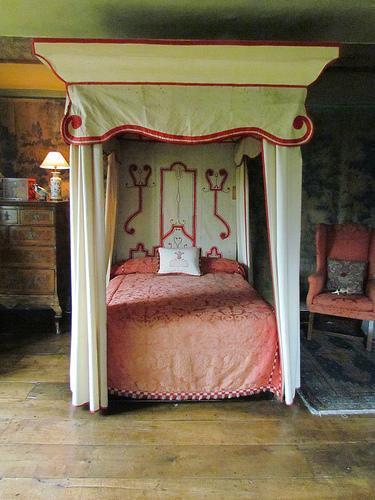How many lamps in the room?
Give a very brief answer. 1. How many dressers in the bedroom?
Give a very brief answer. 1. How many pillows are visible on the bed?
Give a very brief answer. 2. How many chairs are visible in this photo?
Give a very brief answer. 1. 